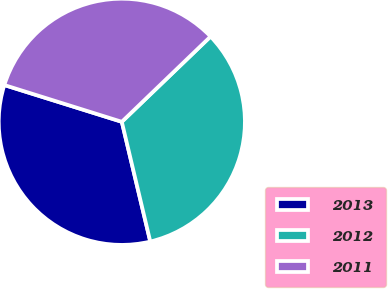Convert chart. <chart><loc_0><loc_0><loc_500><loc_500><pie_chart><fcel>2013<fcel>2012<fcel>2011<nl><fcel>33.54%<fcel>33.47%<fcel>32.99%<nl></chart> 